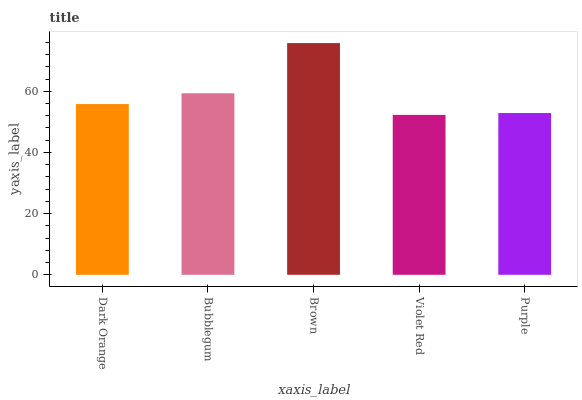Is Violet Red the minimum?
Answer yes or no. Yes. Is Brown the maximum?
Answer yes or no. Yes. Is Bubblegum the minimum?
Answer yes or no. No. Is Bubblegum the maximum?
Answer yes or no. No. Is Bubblegum greater than Dark Orange?
Answer yes or no. Yes. Is Dark Orange less than Bubblegum?
Answer yes or no. Yes. Is Dark Orange greater than Bubblegum?
Answer yes or no. No. Is Bubblegum less than Dark Orange?
Answer yes or no. No. Is Dark Orange the high median?
Answer yes or no. Yes. Is Dark Orange the low median?
Answer yes or no. Yes. Is Purple the high median?
Answer yes or no. No. Is Bubblegum the low median?
Answer yes or no. No. 